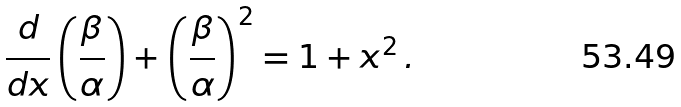Convert formula to latex. <formula><loc_0><loc_0><loc_500><loc_500>\frac { d } { d x } \left ( \frac { \beta } { \alpha } \right ) + \left ( \frac { \beta } { \alpha } \right ) ^ { 2 } = 1 + x ^ { 2 } \, .</formula> 